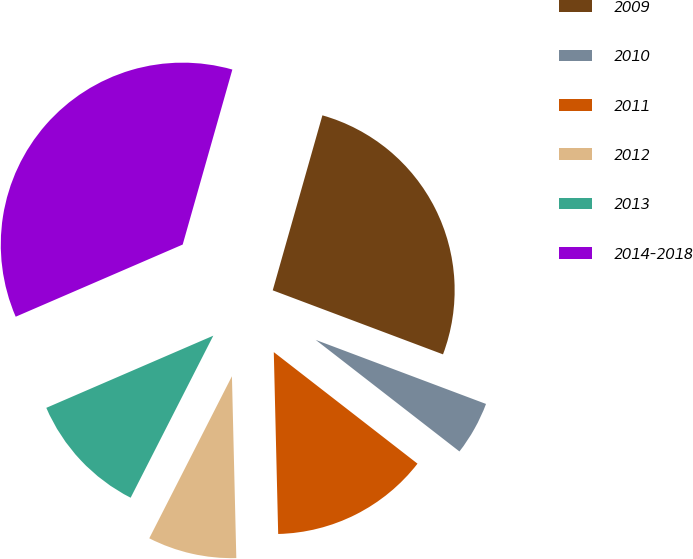<chart> <loc_0><loc_0><loc_500><loc_500><pie_chart><fcel>2009<fcel>2010<fcel>2011<fcel>2012<fcel>2013<fcel>2014-2018<nl><fcel>26.32%<fcel>4.78%<fcel>14.11%<fcel>7.89%<fcel>11.0%<fcel>35.89%<nl></chart> 